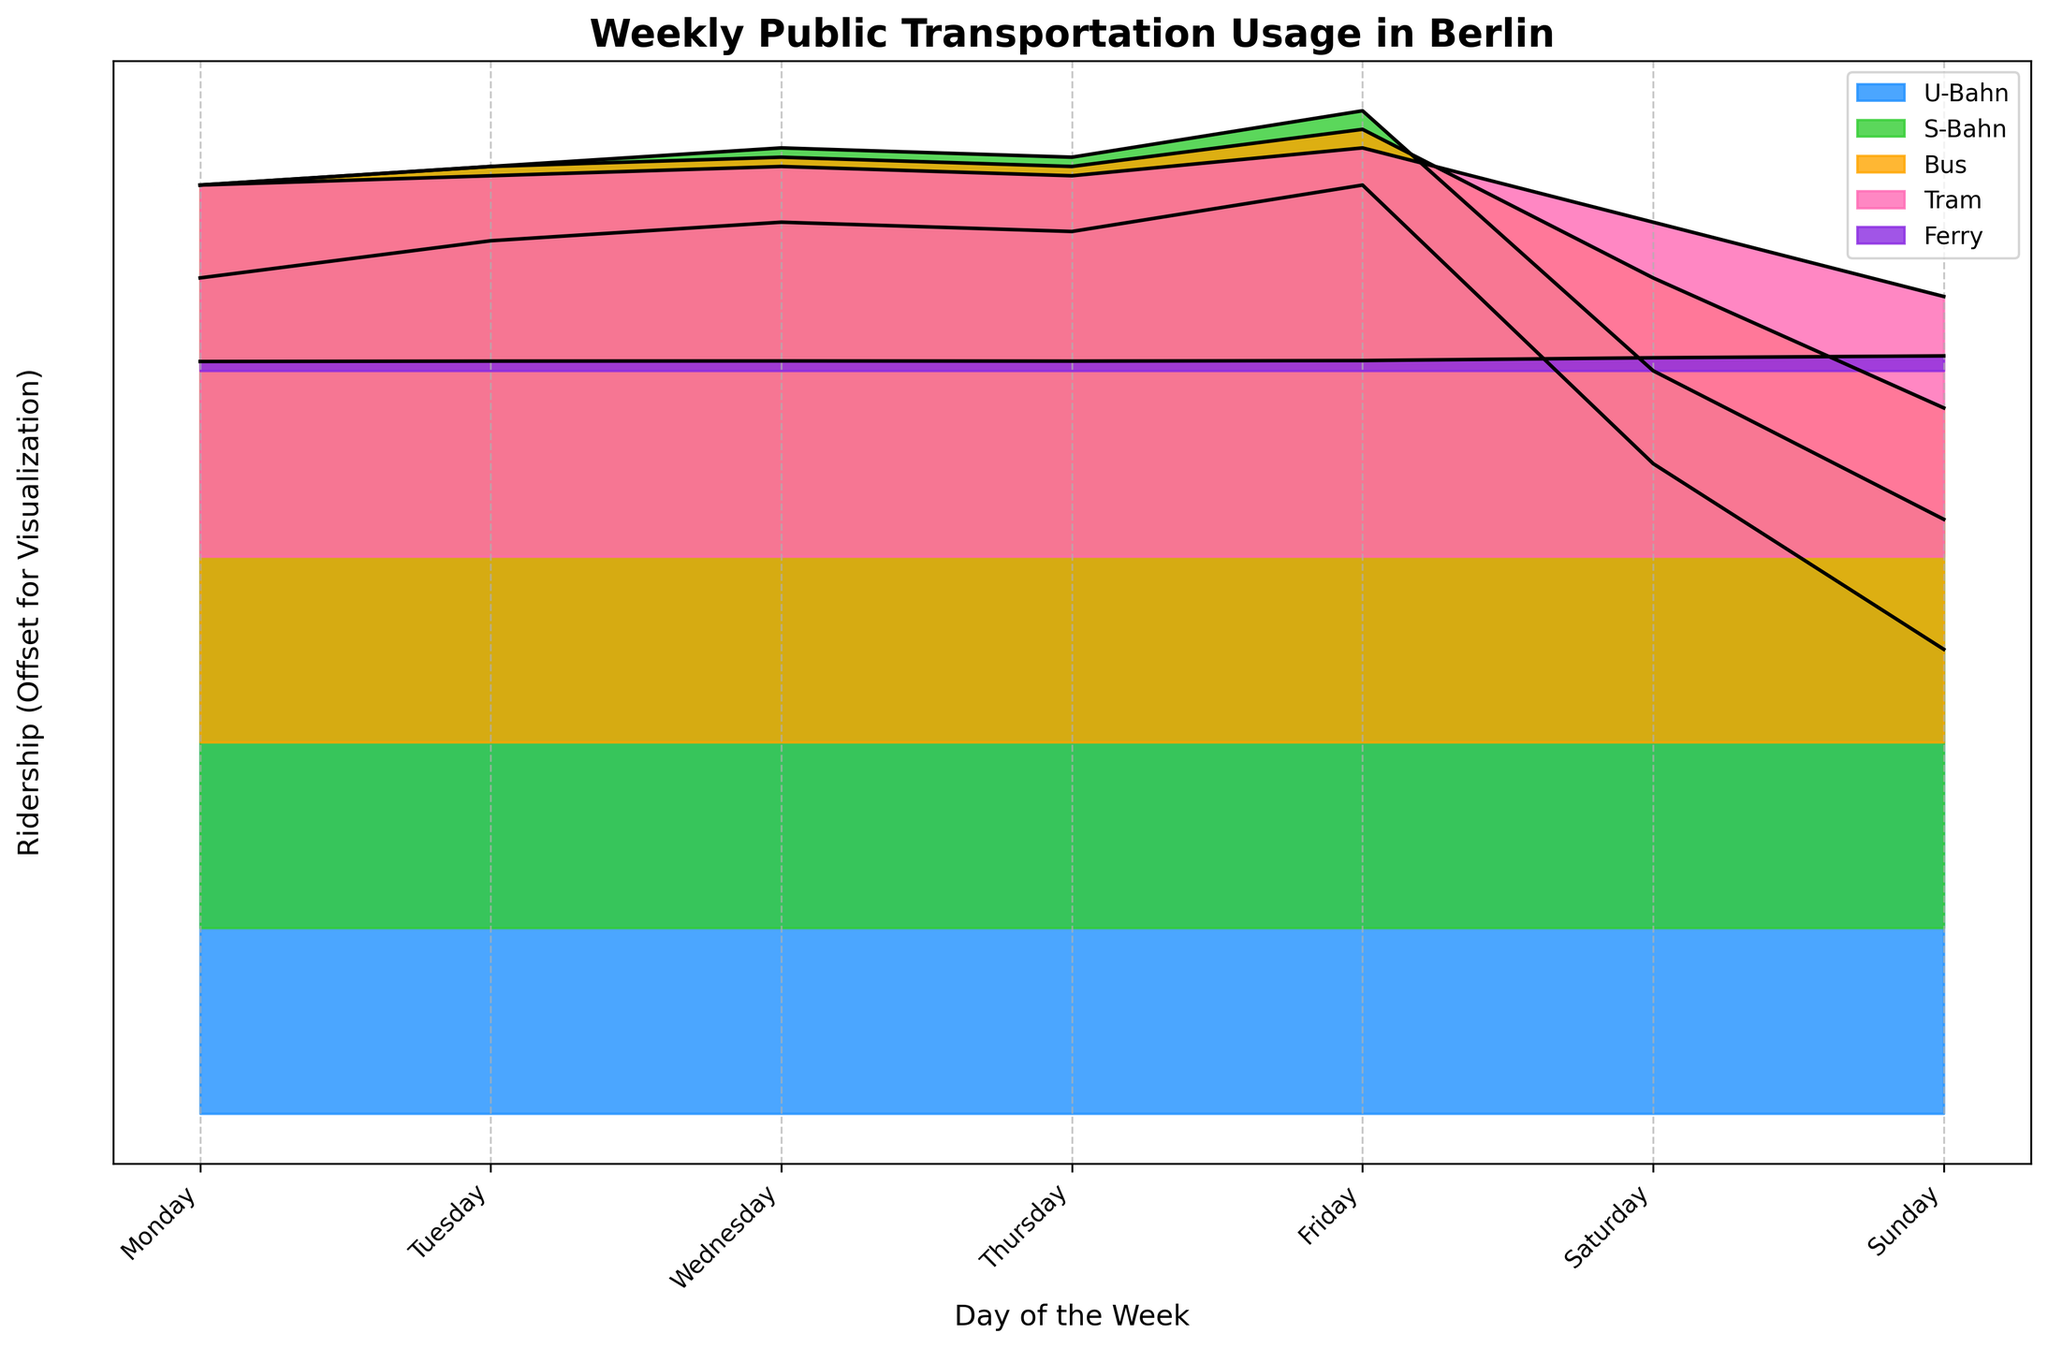What is the title of the figure? The title of the figure is prominently displayed at the top of the plot.
Answer: Weekly Public Transportation Usage in Berlin What are the modes of transportation compared in the figure? The figure uses different colors and labels in the legend to represent each mode of transportation.
Answer: U-Bahn, S-Bahn, Bus, Tram, Ferry Which day of the week has the highest ridership for U-Bahn? By looking at the U-Bahn ridership line, the highest point will indicate the day with the highest ridership.
Answer: Friday Among S-Bahn and Tram, which one has lower ridership on Sundays? By comparing the heights of the filled curves for S-Bahn and Tram on Sundays, the one with the lower peak indicates lower ridership.
Answer: Tram What is the ridership difference between Tuesday and Friday for Bus? Locate the ridership values for Bus on Tuesday and Friday, then subtract the Tuesday value from the Friday value.
Answer: 20,000 What is the trend in ridership for Ferries over the week? Observe the Ferry line to determine if the ridership generally increases, decreases, or stays the same through the days of the week.
Answer: Increases Which day shows the largest decline in ridership from the previous day for S-Bahn? Compare the difference in ridership values from day to day for S-Bahn to identify the largest decline.
Answer: Saturday How do Tram ridership values on weekdays compare to weekend values? Look at the filled curves for Tram on weekdays (Monday to Friday) and compare them to weekend values (Saturday and Sunday) to see which are generally higher or lower.
Answer: Higher on weekdays Between Tuesday and Thursday, which day has higher ridership for U-Bahn? By comparing the heights of the filled curves for U-Bahn on Tuesday and Thursday, the higher peak indicates the day with higher ridership.
Answer: Wednesday What is the ridership value of Buses on Thursday? Find the point on the Bus line corresponding to Thursday by checking the label and reading the value from the y-axis offset.
Answer: 310,000 